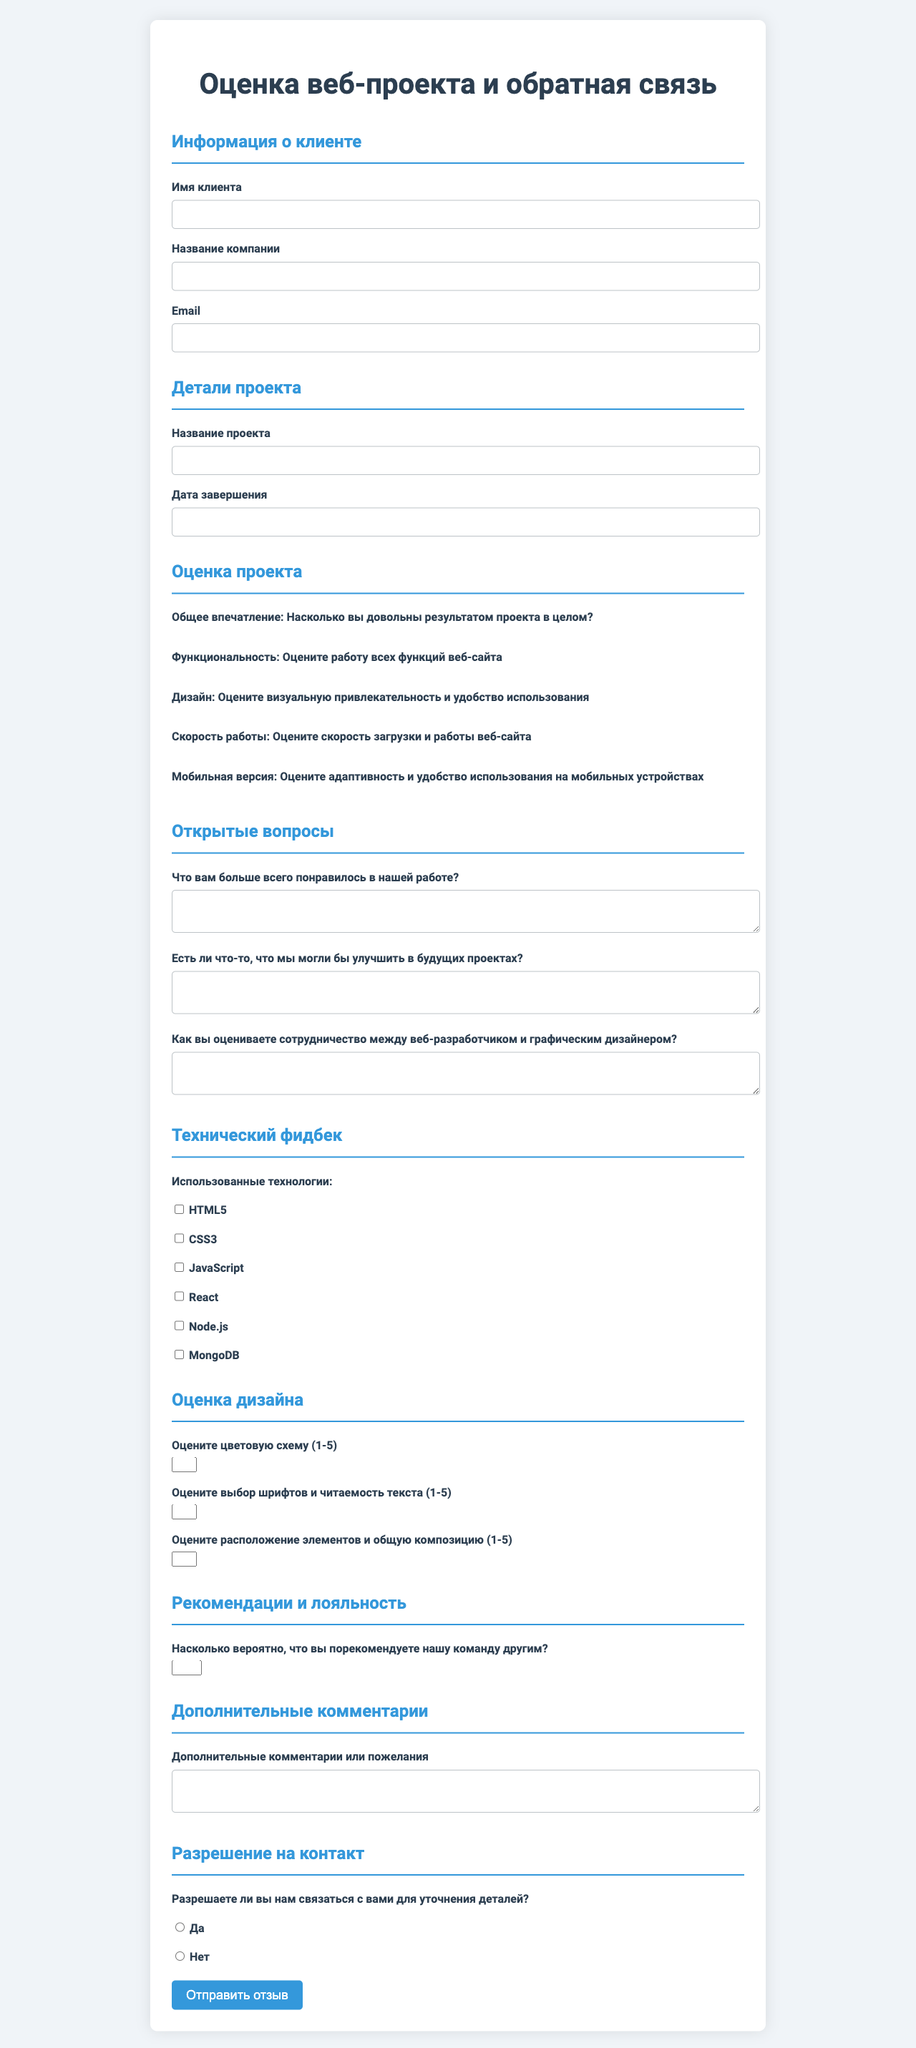what is the title of the form? The title of the form is specified in the document's header, which is "Оценка веб-проекта и обратная связь."
Answer: Оценка веб-проекта и обратная связь who is the client? The client's information is located in the client info section, indicating the client's name is required.
Answer: Имя клиента what is the project name? The name of the project can be found in the project details section, which specifies it as a required field.
Answer: Название проекта what is the completion date of the project? The completion date is listed in the project details section, indicating it’s a field that needs to be filled out.
Answer: Дата завершения how many rating categories are there? The document includes several rating categories that users are asked to evaluate, specifically listed in a section of the form.
Answer: 5 what is the maximum score for functionality? The rating categories specify that functionality is rated on a scale of 5, indicating the highest possible score.
Answer: 5 how many open-ended questions are included? The document lists open-ended questions in a specific section, clearly indicating how many there are.
Answer: 3 what technology is used for the project? The technical feedback section provides a list of technologies that were used in the project, which includes several items.
Answer: HTML5, CSS3, JavaScript, React, Node.js, MongoDB how likely are clients to recommend the team on a scale of 10? The recommendation and loyalty section states a question that asks for a rating on a scale of 10, highlighting the scoring range.
Answer: 10 